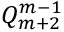Convert formula to latex. <formula><loc_0><loc_0><loc_500><loc_500>Q _ { m + 2 } ^ { m - 1 }</formula> 